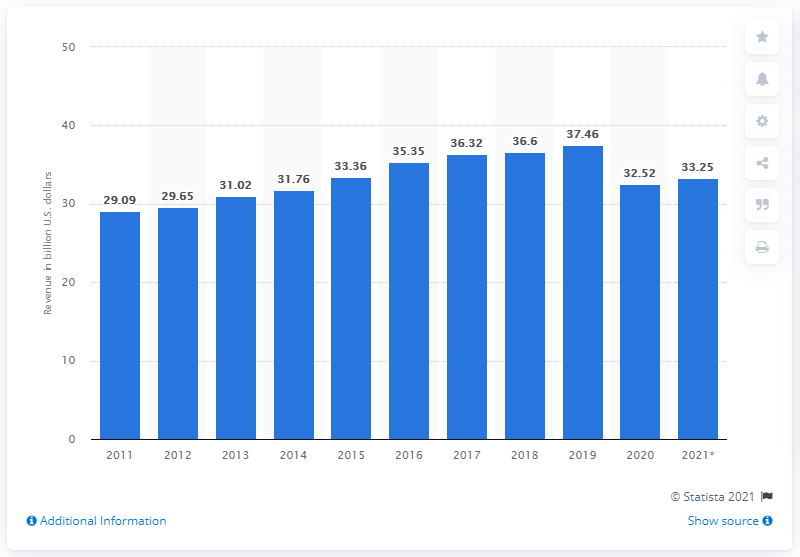Give some essential details in this illustration. The gym, health and fitness club industry in the United States had a market size of approximately 31.76 billion dollars in 2020. In 2021, the market size of the fitness club industry in the United States was approximately 33.25. 